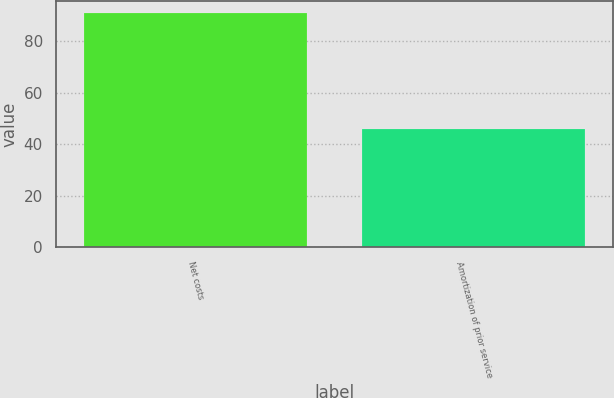<chart> <loc_0><loc_0><loc_500><loc_500><bar_chart><fcel>Net costs<fcel>Amortization of prior service<nl><fcel>91<fcel>46<nl></chart> 